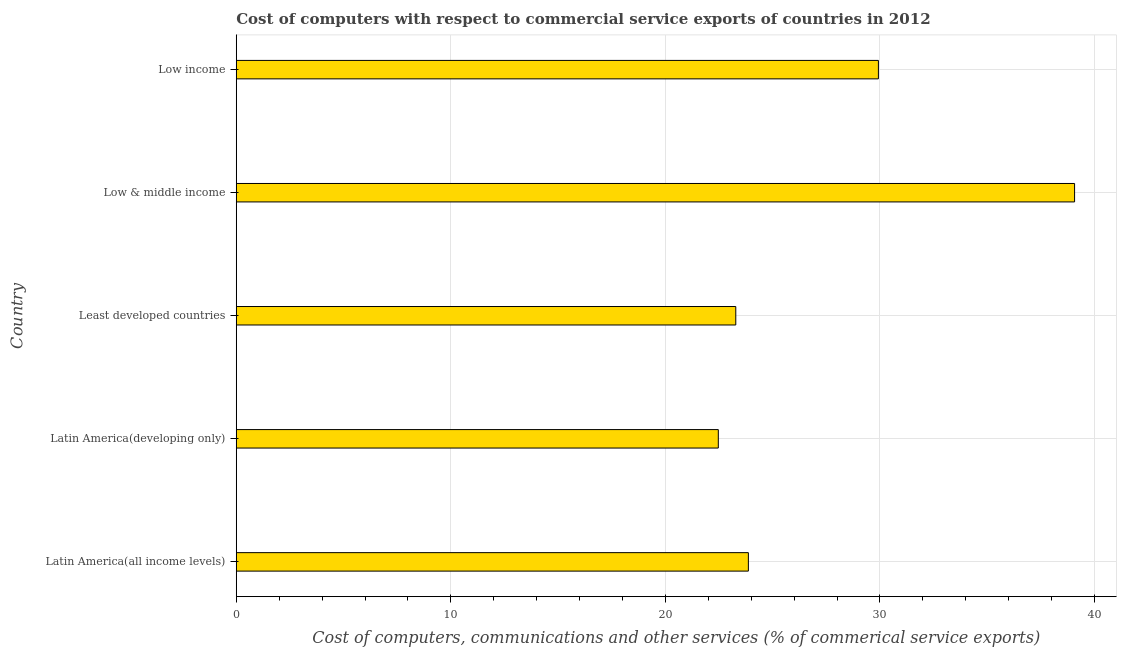Does the graph contain any zero values?
Your answer should be very brief. No. What is the title of the graph?
Make the answer very short. Cost of computers with respect to commercial service exports of countries in 2012. What is the label or title of the X-axis?
Offer a very short reply. Cost of computers, communications and other services (% of commerical service exports). What is the cost of communications in Low & middle income?
Provide a short and direct response. 39.07. Across all countries, what is the maximum cost of communications?
Give a very brief answer. 39.07. Across all countries, what is the minimum  computer and other services?
Your answer should be very brief. 22.47. In which country was the  computer and other services maximum?
Your response must be concise. Low & middle income. In which country was the cost of communications minimum?
Give a very brief answer. Latin America(developing only). What is the sum of the  computer and other services?
Your response must be concise. 138.61. What is the difference between the cost of communications in Latin America(all income levels) and Latin America(developing only)?
Offer a very short reply. 1.4. What is the average cost of communications per country?
Provide a short and direct response. 27.72. What is the median cost of communications?
Your response must be concise. 23.87. What is the ratio of the cost of communications in Latin America(all income levels) to that in Least developed countries?
Your answer should be compact. 1.02. What is the difference between the highest and the second highest  computer and other services?
Ensure brevity in your answer.  9.14. What is the difference between the highest and the lowest  computer and other services?
Offer a terse response. 16.6. In how many countries, is the  computer and other services greater than the average  computer and other services taken over all countries?
Give a very brief answer. 2. How many countries are there in the graph?
Offer a very short reply. 5. What is the Cost of computers, communications and other services (% of commerical service exports) of Latin America(all income levels)?
Your answer should be compact. 23.87. What is the Cost of computers, communications and other services (% of commerical service exports) in Latin America(developing only)?
Ensure brevity in your answer.  22.47. What is the Cost of computers, communications and other services (% of commerical service exports) in Least developed countries?
Provide a succinct answer. 23.28. What is the Cost of computers, communications and other services (% of commerical service exports) in Low & middle income?
Offer a very short reply. 39.07. What is the Cost of computers, communications and other services (% of commerical service exports) in Low income?
Ensure brevity in your answer.  29.93. What is the difference between the Cost of computers, communications and other services (% of commerical service exports) in Latin America(all income levels) and Latin America(developing only)?
Provide a succinct answer. 1.4. What is the difference between the Cost of computers, communications and other services (% of commerical service exports) in Latin America(all income levels) and Least developed countries?
Ensure brevity in your answer.  0.59. What is the difference between the Cost of computers, communications and other services (% of commerical service exports) in Latin America(all income levels) and Low & middle income?
Your answer should be compact. -15.2. What is the difference between the Cost of computers, communications and other services (% of commerical service exports) in Latin America(all income levels) and Low income?
Offer a terse response. -6.06. What is the difference between the Cost of computers, communications and other services (% of commerical service exports) in Latin America(developing only) and Least developed countries?
Your answer should be very brief. -0.81. What is the difference between the Cost of computers, communications and other services (% of commerical service exports) in Latin America(developing only) and Low & middle income?
Provide a short and direct response. -16.6. What is the difference between the Cost of computers, communications and other services (% of commerical service exports) in Latin America(developing only) and Low income?
Provide a succinct answer. -7.46. What is the difference between the Cost of computers, communications and other services (% of commerical service exports) in Least developed countries and Low & middle income?
Give a very brief answer. -15.79. What is the difference between the Cost of computers, communications and other services (% of commerical service exports) in Least developed countries and Low income?
Offer a terse response. -6.65. What is the difference between the Cost of computers, communications and other services (% of commerical service exports) in Low & middle income and Low income?
Your response must be concise. 9.14. What is the ratio of the Cost of computers, communications and other services (% of commerical service exports) in Latin America(all income levels) to that in Latin America(developing only)?
Provide a succinct answer. 1.06. What is the ratio of the Cost of computers, communications and other services (% of commerical service exports) in Latin America(all income levels) to that in Low & middle income?
Keep it short and to the point. 0.61. What is the ratio of the Cost of computers, communications and other services (% of commerical service exports) in Latin America(all income levels) to that in Low income?
Offer a terse response. 0.8. What is the ratio of the Cost of computers, communications and other services (% of commerical service exports) in Latin America(developing only) to that in Least developed countries?
Offer a terse response. 0.96. What is the ratio of the Cost of computers, communications and other services (% of commerical service exports) in Latin America(developing only) to that in Low & middle income?
Your answer should be very brief. 0.57. What is the ratio of the Cost of computers, communications and other services (% of commerical service exports) in Latin America(developing only) to that in Low income?
Keep it short and to the point. 0.75. What is the ratio of the Cost of computers, communications and other services (% of commerical service exports) in Least developed countries to that in Low & middle income?
Keep it short and to the point. 0.6. What is the ratio of the Cost of computers, communications and other services (% of commerical service exports) in Least developed countries to that in Low income?
Your answer should be very brief. 0.78. What is the ratio of the Cost of computers, communications and other services (% of commerical service exports) in Low & middle income to that in Low income?
Your answer should be compact. 1.3. 